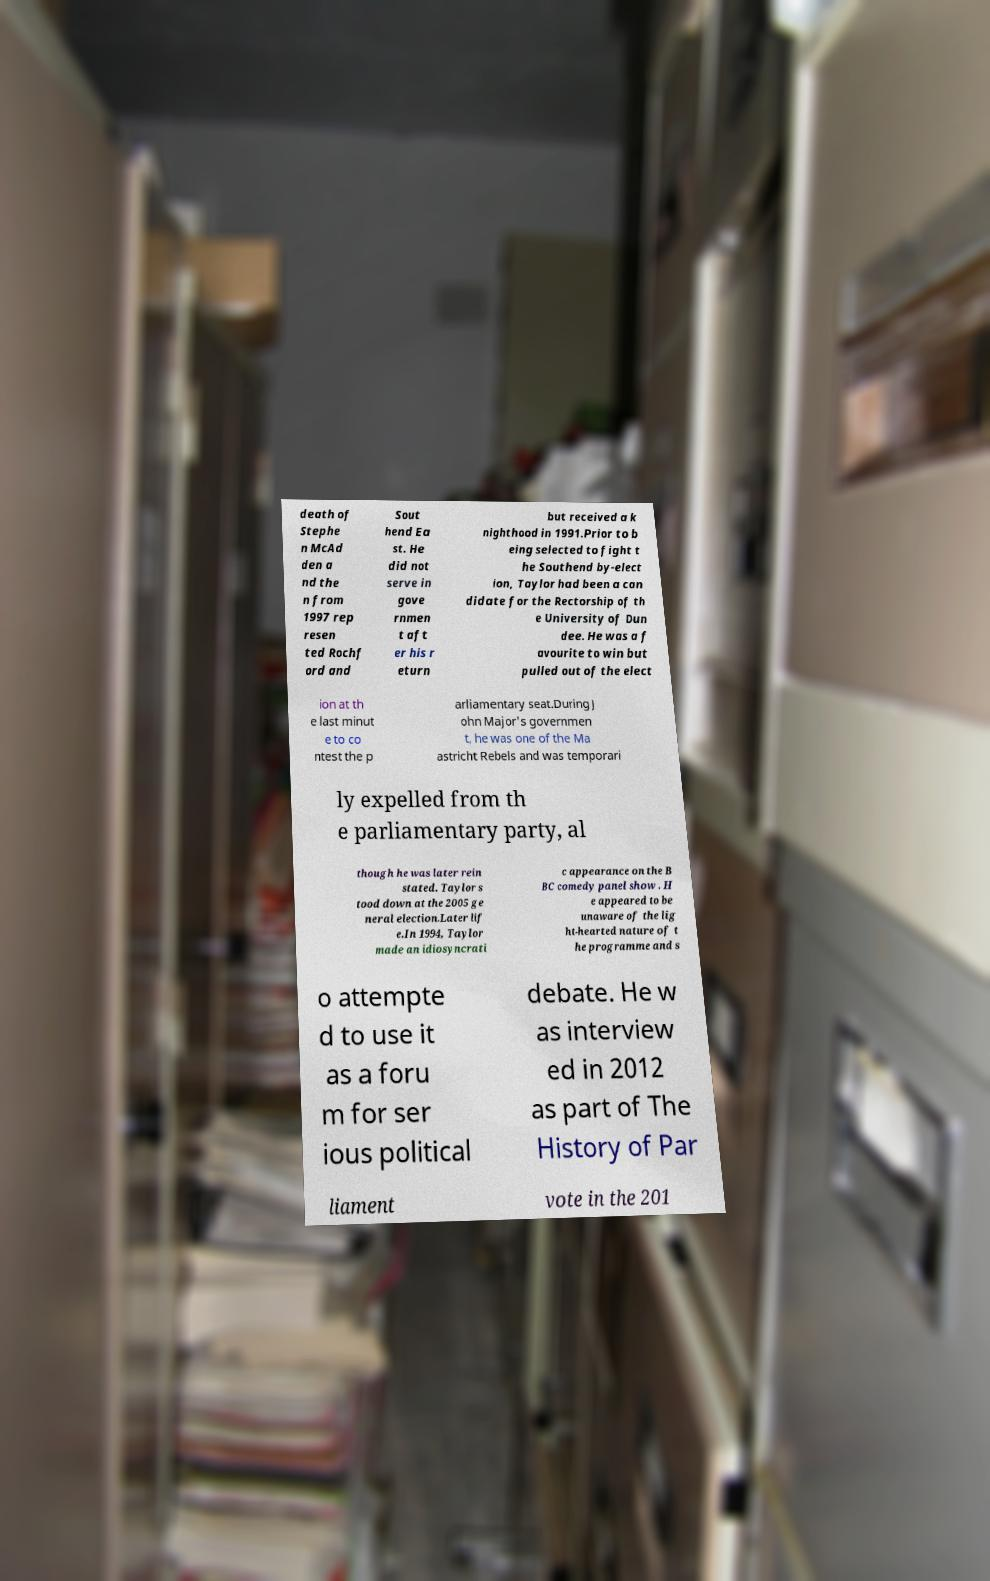What messages or text are displayed in this image? I need them in a readable, typed format. death of Stephe n McAd den a nd the n from 1997 rep resen ted Rochf ord and Sout hend Ea st. He did not serve in gove rnmen t aft er his r eturn but received a k nighthood in 1991.Prior to b eing selected to fight t he Southend by-elect ion, Taylor had been a can didate for the Rectorship of th e University of Dun dee. He was a f avourite to win but pulled out of the elect ion at th e last minut e to co ntest the p arliamentary seat.During J ohn Major's governmen t, he was one of the Ma astricht Rebels and was temporari ly expelled from th e parliamentary party, al though he was later rein stated. Taylor s tood down at the 2005 ge neral election.Later lif e.In 1994, Taylor made an idiosyncrati c appearance on the B BC comedy panel show . H e appeared to be unaware of the lig ht-hearted nature of t he programme and s o attempte d to use it as a foru m for ser ious political debate. He w as interview ed in 2012 as part of The History of Par liament vote in the 201 